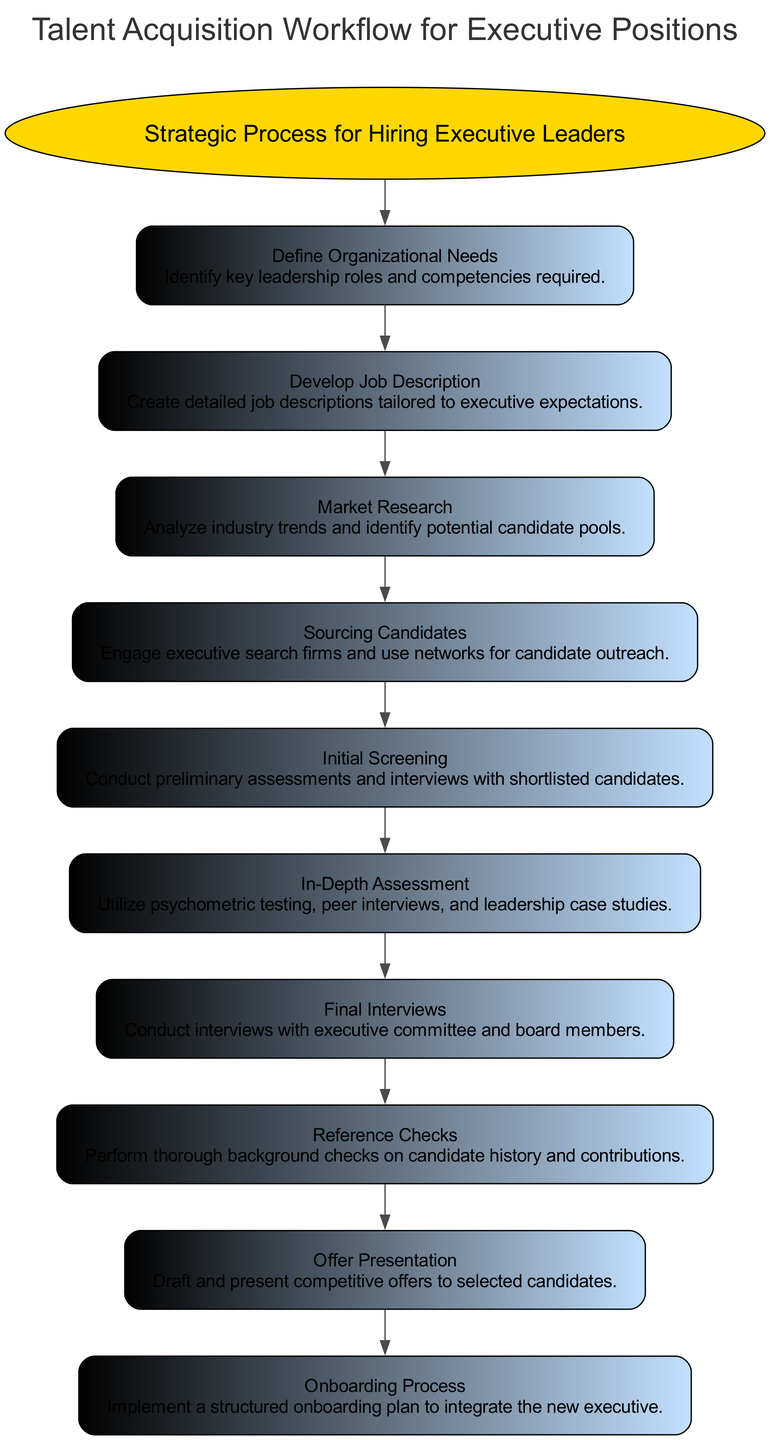What is the first stage in the talent acquisition workflow? The first stage in the workflow is specified directly in the diagram as "Define Organizational Needs," which is the initial point for the flow of operations.
Answer: Define Organizational Needs How many stages are included in the talent acquisition workflow? By counting the stages listed in the diagram, there are a total of ten distinct stages that encompass the entire talent acquisition process.
Answer: 10 Which stage involves performing thorough background checks on candidate history? Referring to the diagram, the stage dedicated to background checks is identified as "Reference Checks," which details the verification process for candidates.
Answer: Reference Checks What is the last stage in the talent acquisition workflow? The diagram indicates that the concluding stage is "Onboarding Process," which signifies the final step of integrating a new executive into the organization.
Answer: Onboarding Process Which node directly follows "Initial Screening" in the workflow? In following the flow of the diagram from "Initial Screening," the next logical step is "In-Depth Assessment," meaning that these stages are sequential in the process.
Answer: In-Depth Assessment How is "Market Research" connected to the other stages? Within the context of the diagram, "Market Research" is connected sequentially, and it comes after the "Develop Job Description" stage, indicating a progression in the workflow.
Answer: After Develop Job Description What do we achieve in the "Offer Presentation" stage? The "Offer Presentation" stage is crucial as it involves drafting and presenting competitive offers to selected candidates, which is key in the hiring process.
Answer: Competitive offers How many times does the connection flow from "Overview" to the subsequent stages? The connection from "Overview" occurs once, leading to the first stage, and thereafter each stage connects sequentially down the flow without returning to the overview, indicating a single flow.
Answer: Once What stage involves analyzing industry trends? The diagram stipulates that the stage dedicated to the analysis of industry trends is termed "Market Research," which focuses on understanding external factors affecting talent acquisition.
Answer: Market Research 